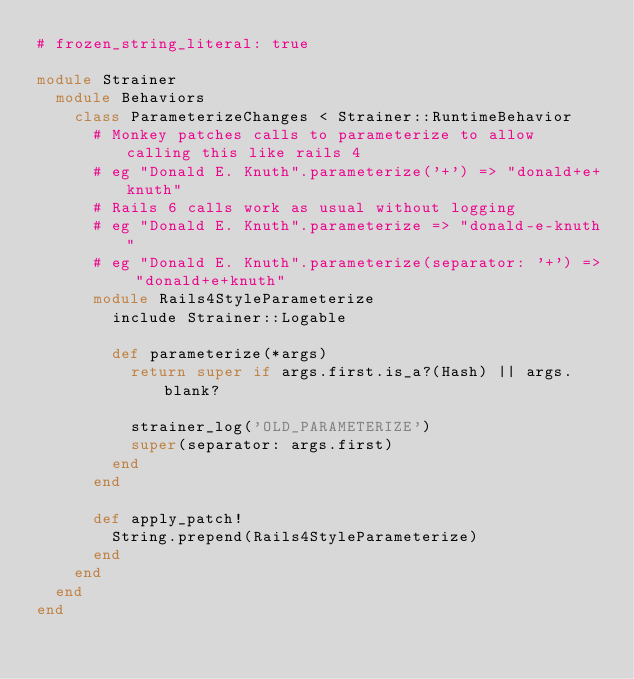Convert code to text. <code><loc_0><loc_0><loc_500><loc_500><_Ruby_># frozen_string_literal: true

module Strainer
  module Behaviors
    class ParameterizeChanges < Strainer::RuntimeBehavior
      # Monkey patches calls to parameterize to allow calling this like rails 4
      # eg "Donald E. Knuth".parameterize('+') => "donald+e+knuth"
      # Rails 6 calls work as usual without logging
      # eg "Donald E. Knuth".parameterize => "donald-e-knuth"
      # eg "Donald E. Knuth".parameterize(separator: '+') => "donald+e+knuth"
      module Rails4StyleParameterize
        include Strainer::Logable

        def parameterize(*args)
          return super if args.first.is_a?(Hash) || args.blank?

          strainer_log('OLD_PARAMETERIZE')
          super(separator: args.first)
        end
      end

      def apply_patch!
        String.prepend(Rails4StyleParameterize)
      end
    end
  end
end
</code> 